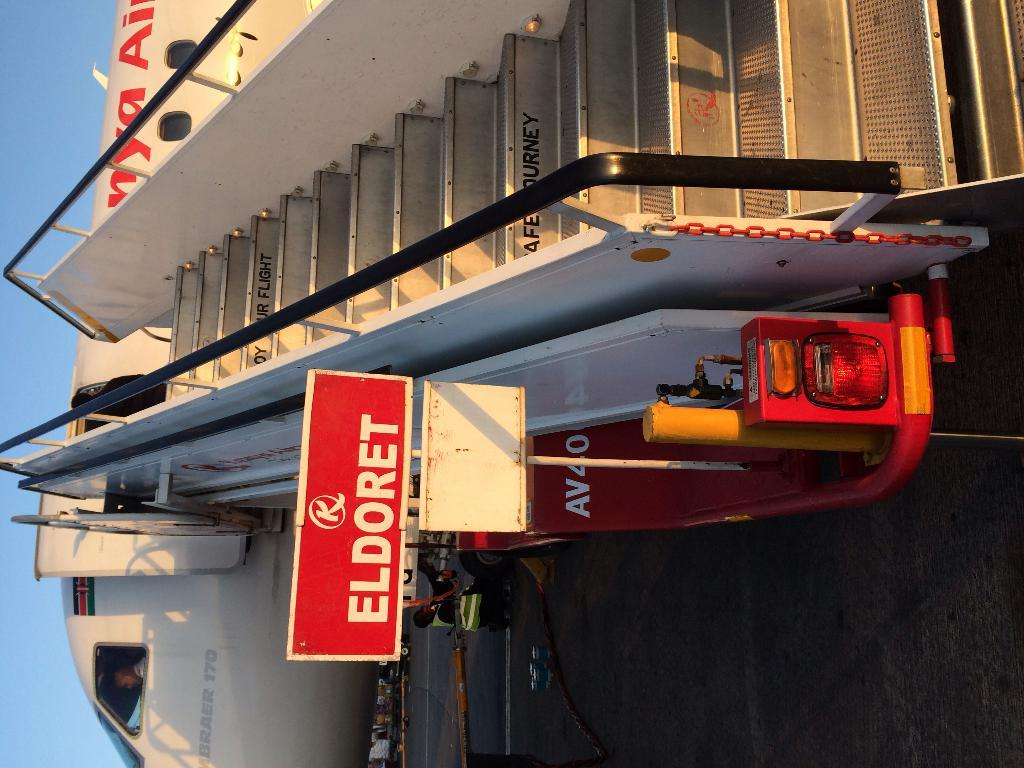Provide a one-sentence caption for the provided image. A portable stair ramp that says Eldoret is attached to a plane. 